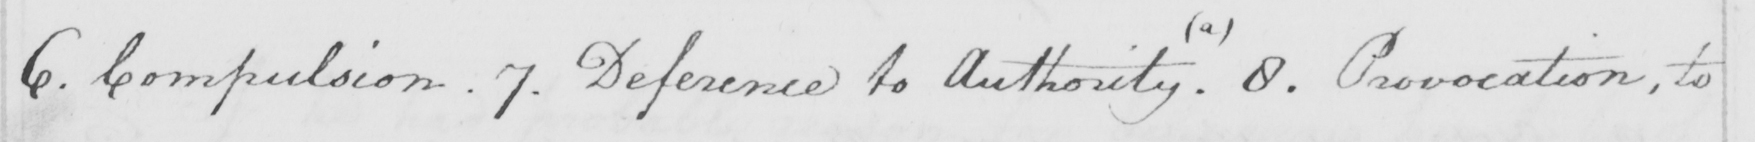Transcribe the text shown in this historical manuscript line. 6 . Compulsion . 7 . Deference to Authority  ( a )  . 8 . Provocation , to 